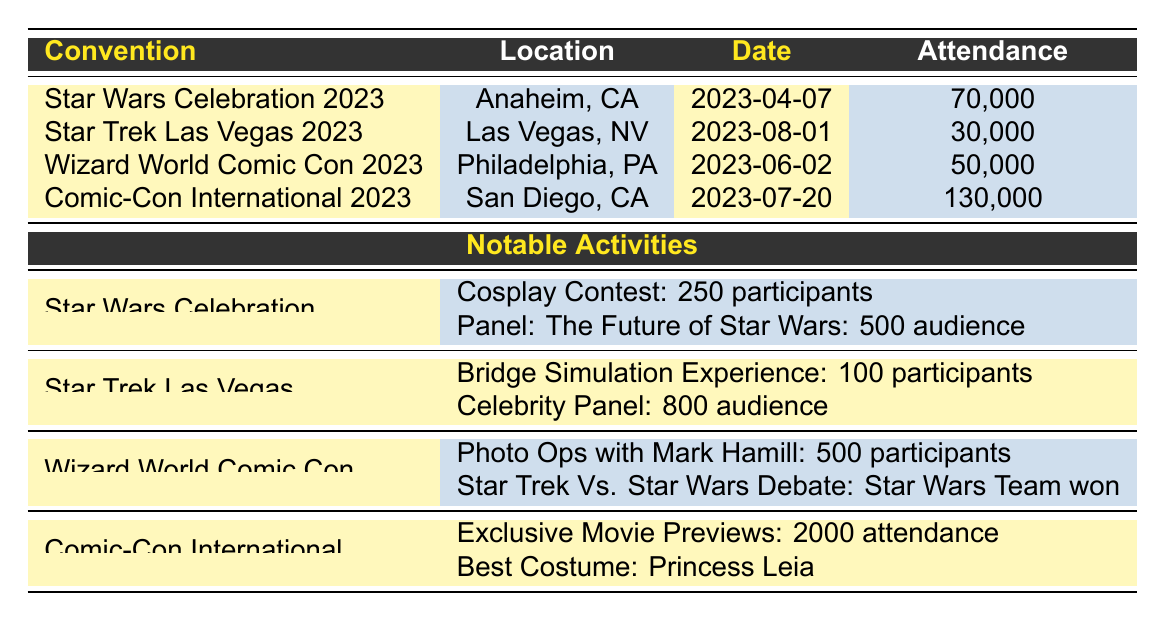What is the date of the Star Wars Celebration 2023? The table lists Star Wars Celebration 2023 with the date listed under the "Date" column as 2023-04-07.
Answer: 2023-04-07 How many participants were in the Cosplay Contest at Star Wars Celebration 2023? The activity "Cosplay Contest" is mentioned in the row for Star Wars Celebration 2023, and it states there were 250 participants.
Answer: 250 What was the total attendance of all fan conventions listed in the table? Summing the attendance values: 70,000 (Star Wars Celebration) + 30,000 (Star Trek Las Vegas) + 50,000 (Wizard World Comic Con) + 130,000 (Comic-Con International) = 280,000.
Answer: 280,000 Did the Star Wars team win the Star Trek Vs. Star Wars Debate at Wizard World Comic Con? The table states that the winner of the "Star Trek Vs. Star Wars Debate" activity at Wizard World Comic Con was "Star Wars Team." Therefore, the statement is true.
Answer: Yes Which convention had the highest attendance and what was that attendance? Looking through the attendance numbers, Comic-Con International 2023 has the highest attendance at 130,000, found in the last row of the table.
Answer: Comic-Con International 2023, 130,000 How many speakers participated in the Celebrity Panel at Star Trek Las Vegas 2023? For Star Trek Las Vegas, the activity "Celebrity Panel: Star Trek Legacy" has a note that lists 5 speakers involved. This information is found in the activities section related to that convention.
Answer: 5 What was the top award mentioned in the art show exhibition at Star Trek Las Vegas 2023? In the activities listed for Star Trek Las Vegas, the "Art Show Exhibition" activity mentions a top award, which is "Best Starship Artwork," found in the corresponding row.
Answer: Best Starship Artwork What is the average attendance for the four conventions listed? First, calculate the total attendance as 280,000 (previously found), then divide by the number of conventions which is 4. So, 280,000 / 4 = 70,000.
Answer: 70,000 Which activity had the lowest number of participants across all conventions listed? Review the participants for each activity: Cosplay Contest (250), Bridge Simulation Experience (100), Photo Ops with Stars (500), Droid Workshop (75). The Droid Workshop had the lowest number at 75 participants.
Answer: Droid Workshop, 75 